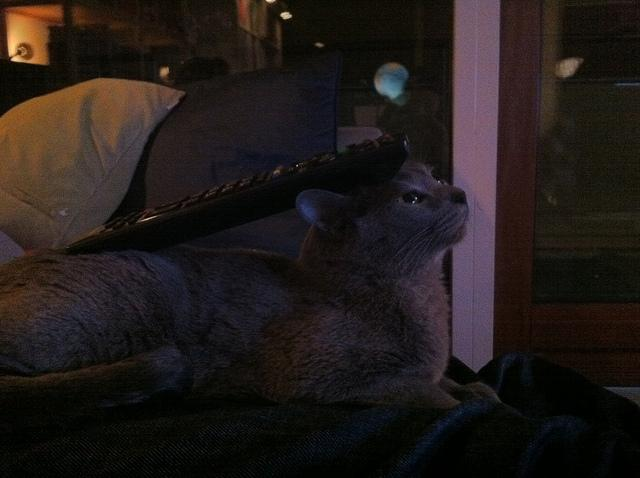What item is the cat balancing on their head?

Choices:
A) puppy
B) remote control
C) banana
D) apple remote control 